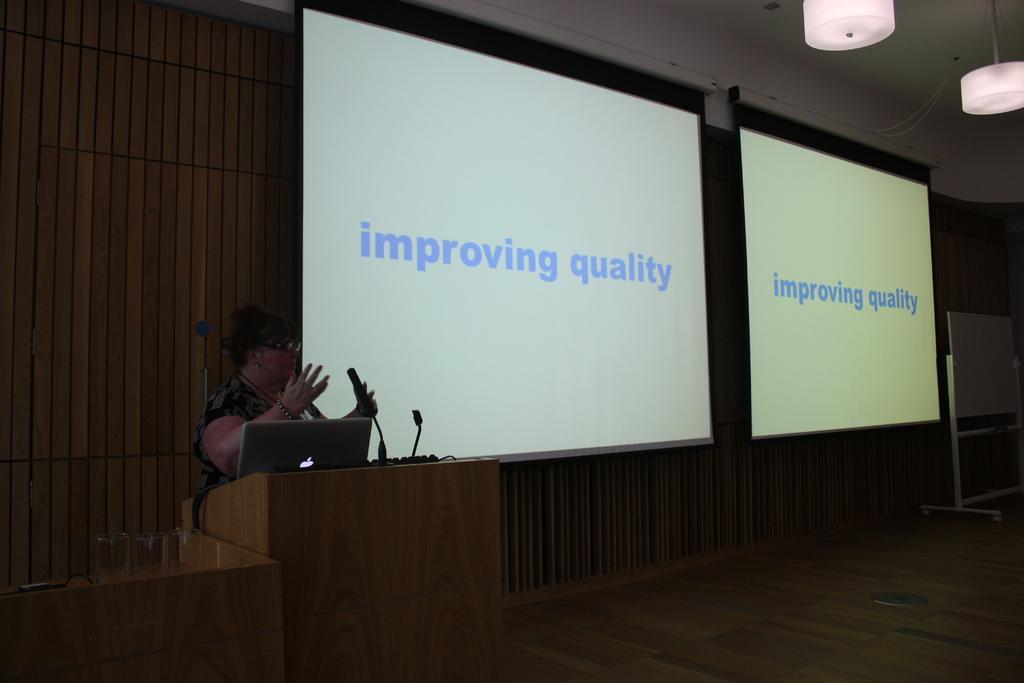How would you summarize this image in a sentence or two? In this image I can see a woman taking in front of the mike and there is a laptop placed, side I can see display on the boards. 